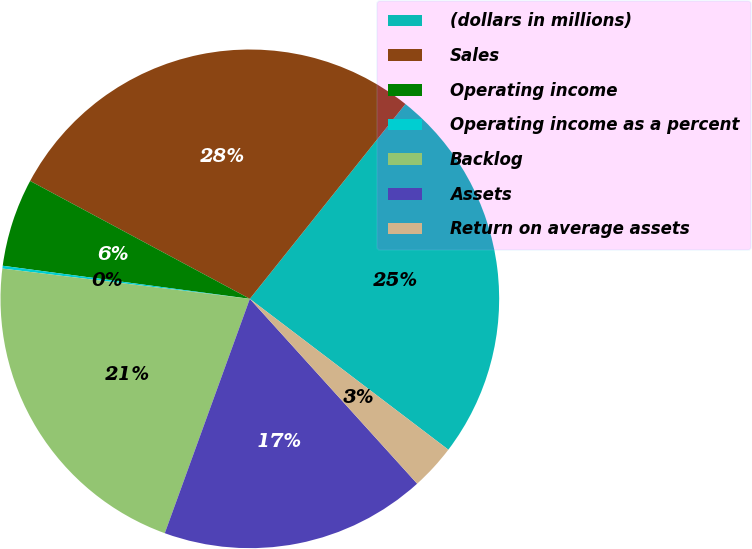<chart> <loc_0><loc_0><loc_500><loc_500><pie_chart><fcel>(dollars in millions)<fcel>Sales<fcel>Operating income<fcel>Operating income as a percent<fcel>Backlog<fcel>Assets<fcel>Return on average assets<nl><fcel>24.62%<fcel>27.89%<fcel>5.72%<fcel>0.18%<fcel>21.4%<fcel>17.25%<fcel>2.95%<nl></chart> 